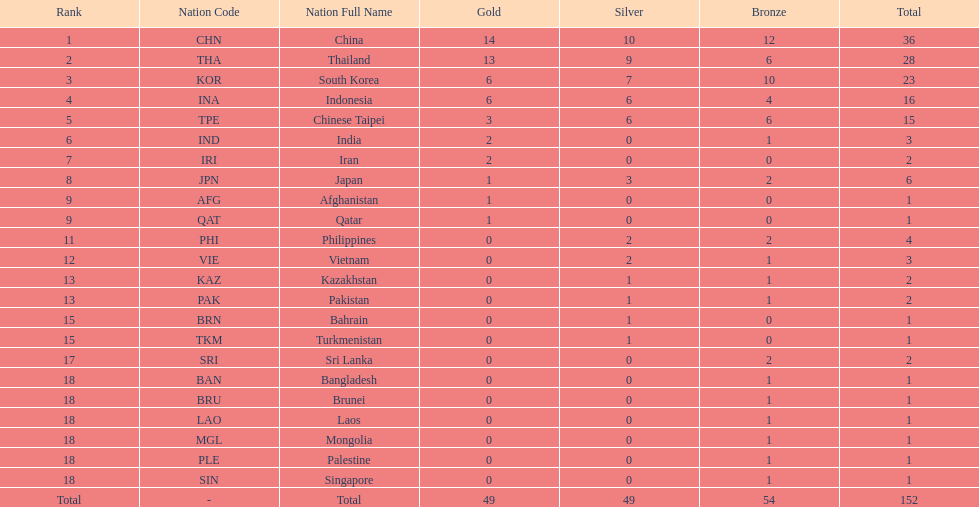Can you give me this table as a dict? {'header': ['Rank', 'Nation Code', 'Nation Full Name', 'Gold', 'Silver', 'Bronze', 'Total'], 'rows': [['1', 'CHN', 'China', '14', '10', '12', '36'], ['2', 'THA', 'Thailand', '13', '9', '6', '28'], ['3', 'KOR', 'South Korea', '6', '7', '10', '23'], ['4', 'INA', 'Indonesia', '6', '6', '4', '16'], ['5', 'TPE', 'Chinese Taipei', '3', '6', '6', '15'], ['6', 'IND', 'India', '2', '0', '1', '3'], ['7', 'IRI', 'Iran', '2', '0', '0', '2'], ['8', 'JPN', 'Japan', '1', '3', '2', '6'], ['9', 'AFG', 'Afghanistan', '1', '0', '0', '1'], ['9', 'QAT', 'Qatar', '1', '0', '0', '1'], ['11', 'PHI', 'Philippines', '0', '2', '2', '4'], ['12', 'VIE', 'Vietnam', '0', '2', '1', '3'], ['13', 'KAZ', 'Kazakhstan', '0', '1', '1', '2'], ['13', 'PAK', 'Pakistan', '0', '1', '1', '2'], ['15', 'BRN', 'Bahrain', '0', '1', '0', '1'], ['15', 'TKM', 'Turkmenistan', '0', '1', '0', '1'], ['17', 'SRI', 'Sri Lanka', '0', '0', '2', '2'], ['18', 'BAN', 'Bangladesh', '0', '0', '1', '1'], ['18', 'BRU', 'Brunei', '0', '0', '1', '1'], ['18', 'LAO', 'Laos', '0', '0', '1', '1'], ['18', 'MGL', 'Mongolia', '0', '0', '1', '1'], ['18', 'PLE', 'Palestine', '0', '0', '1', '1'], ['18', 'SIN', 'Singapore', '0', '0', '1', '1'], ['Total', '-', 'Total', '49', '49', '54', '152']]} Which nation finished first in total medals earned? China (CHN). 